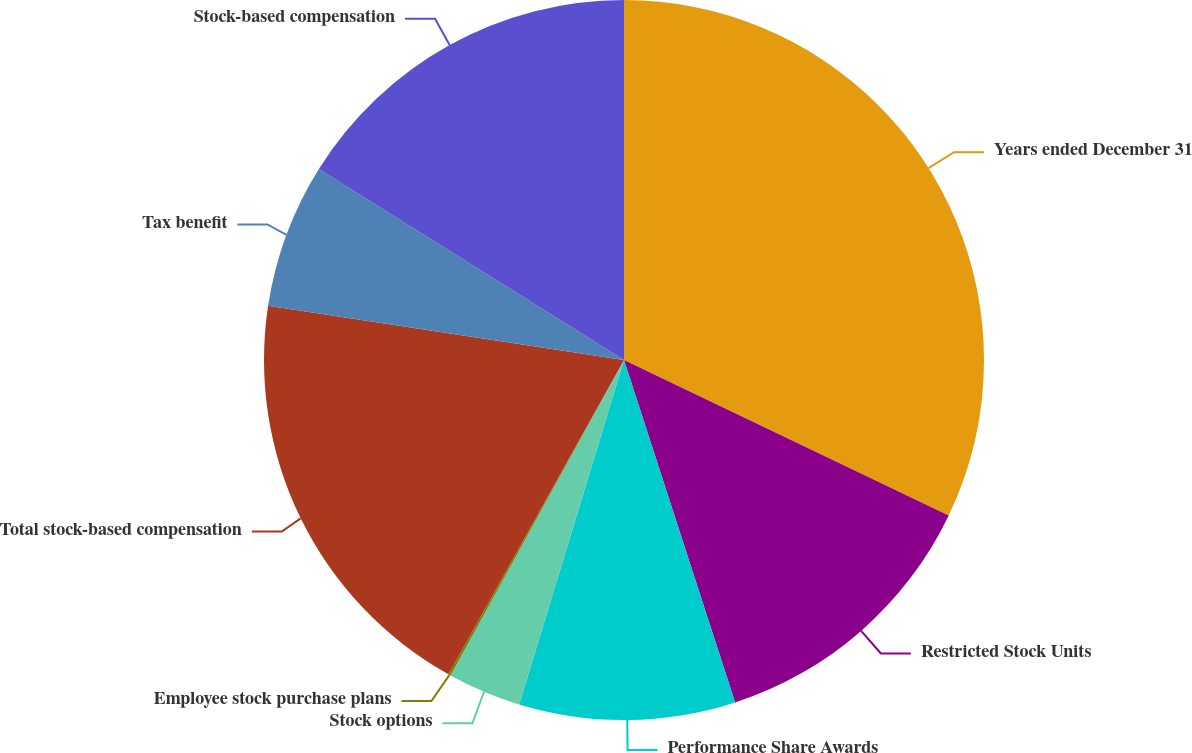Convert chart. <chart><loc_0><loc_0><loc_500><loc_500><pie_chart><fcel>Years ended December 31<fcel>Restricted Stock Units<fcel>Performance Share Awards<fcel>Stock options<fcel>Employee stock purchase plans<fcel>Total stock-based compensation<fcel>Tax benefit<fcel>Stock-based compensation<nl><fcel>32.11%<fcel>12.9%<fcel>9.7%<fcel>3.3%<fcel>0.1%<fcel>19.3%<fcel>6.5%<fcel>16.1%<nl></chart> 